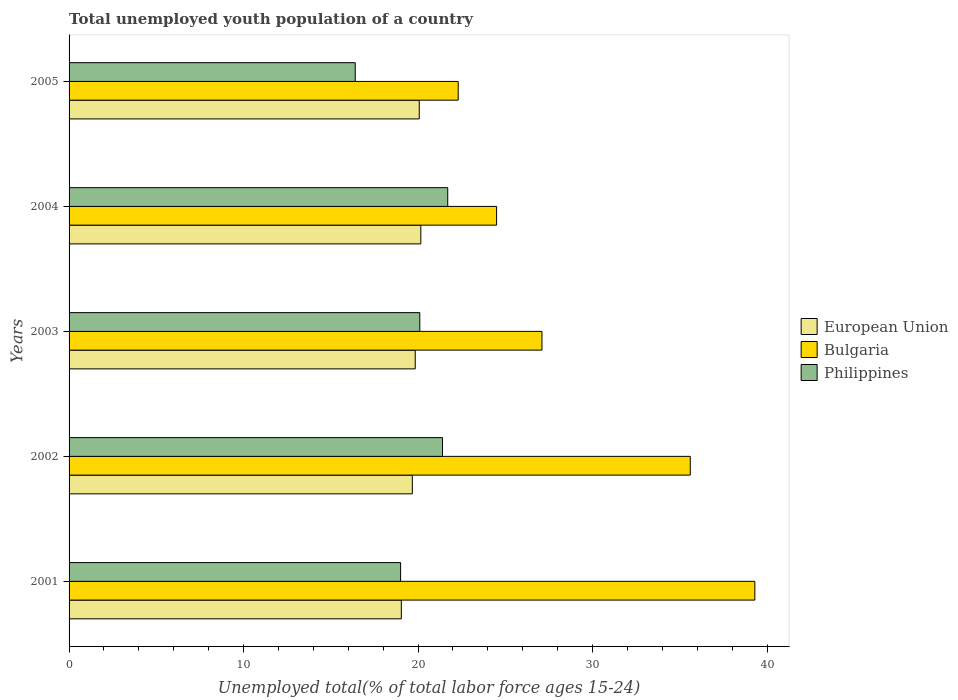How many groups of bars are there?
Give a very brief answer. 5. How many bars are there on the 4th tick from the top?
Give a very brief answer. 3. How many bars are there on the 2nd tick from the bottom?
Provide a succinct answer. 3. In how many cases, is the number of bars for a given year not equal to the number of legend labels?
Ensure brevity in your answer.  0. What is the percentage of total unemployed youth population of a country in European Union in 2001?
Provide a short and direct response. 19.04. Across all years, what is the maximum percentage of total unemployed youth population of a country in Philippines?
Keep it short and to the point. 21.7. Across all years, what is the minimum percentage of total unemployed youth population of a country in Philippines?
Your answer should be compact. 16.4. In which year was the percentage of total unemployed youth population of a country in European Union minimum?
Ensure brevity in your answer.  2001. What is the total percentage of total unemployed youth population of a country in Philippines in the graph?
Your answer should be very brief. 98.6. What is the difference between the percentage of total unemployed youth population of a country in Bulgaria in 2004 and that in 2005?
Offer a very short reply. 2.2. What is the difference between the percentage of total unemployed youth population of a country in Bulgaria in 2005 and the percentage of total unemployed youth population of a country in Philippines in 2001?
Your answer should be compact. 3.3. What is the average percentage of total unemployed youth population of a country in European Union per year?
Ensure brevity in your answer.  19.76. In the year 2002, what is the difference between the percentage of total unemployed youth population of a country in European Union and percentage of total unemployed youth population of a country in Bulgaria?
Offer a terse response. -15.93. What is the ratio of the percentage of total unemployed youth population of a country in European Union in 2003 to that in 2004?
Offer a terse response. 0.98. Is the difference between the percentage of total unemployed youth population of a country in European Union in 2003 and 2004 greater than the difference between the percentage of total unemployed youth population of a country in Bulgaria in 2003 and 2004?
Your answer should be very brief. No. What is the difference between the highest and the second highest percentage of total unemployed youth population of a country in Bulgaria?
Offer a very short reply. 3.7. What is the difference between the highest and the lowest percentage of total unemployed youth population of a country in European Union?
Your answer should be compact. 1.12. What does the 2nd bar from the top in 2003 represents?
Make the answer very short. Bulgaria. Is it the case that in every year, the sum of the percentage of total unemployed youth population of a country in Philippines and percentage of total unemployed youth population of a country in European Union is greater than the percentage of total unemployed youth population of a country in Bulgaria?
Offer a terse response. No. Are the values on the major ticks of X-axis written in scientific E-notation?
Keep it short and to the point. No. Does the graph contain any zero values?
Provide a short and direct response. No. Where does the legend appear in the graph?
Give a very brief answer. Center right. How many legend labels are there?
Provide a succinct answer. 3. What is the title of the graph?
Make the answer very short. Total unemployed youth population of a country. What is the label or title of the X-axis?
Your response must be concise. Unemployed total(% of total labor force ages 15-24). What is the Unemployed total(% of total labor force ages 15-24) in European Union in 2001?
Make the answer very short. 19.04. What is the Unemployed total(% of total labor force ages 15-24) of Bulgaria in 2001?
Give a very brief answer. 39.3. What is the Unemployed total(% of total labor force ages 15-24) in Philippines in 2001?
Provide a succinct answer. 19. What is the Unemployed total(% of total labor force ages 15-24) of European Union in 2002?
Your answer should be compact. 19.67. What is the Unemployed total(% of total labor force ages 15-24) in Bulgaria in 2002?
Give a very brief answer. 35.6. What is the Unemployed total(% of total labor force ages 15-24) in Philippines in 2002?
Your response must be concise. 21.4. What is the Unemployed total(% of total labor force ages 15-24) of European Union in 2003?
Your answer should be compact. 19.84. What is the Unemployed total(% of total labor force ages 15-24) of Bulgaria in 2003?
Your response must be concise. 27.1. What is the Unemployed total(% of total labor force ages 15-24) of Philippines in 2003?
Offer a very short reply. 20.1. What is the Unemployed total(% of total labor force ages 15-24) in European Union in 2004?
Keep it short and to the point. 20.16. What is the Unemployed total(% of total labor force ages 15-24) of Philippines in 2004?
Give a very brief answer. 21.7. What is the Unemployed total(% of total labor force ages 15-24) in European Union in 2005?
Your answer should be compact. 20.07. What is the Unemployed total(% of total labor force ages 15-24) in Bulgaria in 2005?
Provide a succinct answer. 22.3. What is the Unemployed total(% of total labor force ages 15-24) in Philippines in 2005?
Ensure brevity in your answer.  16.4. Across all years, what is the maximum Unemployed total(% of total labor force ages 15-24) in European Union?
Give a very brief answer. 20.16. Across all years, what is the maximum Unemployed total(% of total labor force ages 15-24) in Bulgaria?
Ensure brevity in your answer.  39.3. Across all years, what is the maximum Unemployed total(% of total labor force ages 15-24) in Philippines?
Offer a very short reply. 21.7. Across all years, what is the minimum Unemployed total(% of total labor force ages 15-24) in European Union?
Your answer should be very brief. 19.04. Across all years, what is the minimum Unemployed total(% of total labor force ages 15-24) in Bulgaria?
Make the answer very short. 22.3. Across all years, what is the minimum Unemployed total(% of total labor force ages 15-24) of Philippines?
Keep it short and to the point. 16.4. What is the total Unemployed total(% of total labor force ages 15-24) in European Union in the graph?
Provide a short and direct response. 98.78. What is the total Unemployed total(% of total labor force ages 15-24) in Bulgaria in the graph?
Your response must be concise. 148.8. What is the total Unemployed total(% of total labor force ages 15-24) in Philippines in the graph?
Your answer should be compact. 98.6. What is the difference between the Unemployed total(% of total labor force ages 15-24) of European Union in 2001 and that in 2002?
Offer a terse response. -0.63. What is the difference between the Unemployed total(% of total labor force ages 15-24) of European Union in 2001 and that in 2003?
Keep it short and to the point. -0.8. What is the difference between the Unemployed total(% of total labor force ages 15-24) in Bulgaria in 2001 and that in 2003?
Ensure brevity in your answer.  12.2. What is the difference between the Unemployed total(% of total labor force ages 15-24) of Philippines in 2001 and that in 2003?
Ensure brevity in your answer.  -1.1. What is the difference between the Unemployed total(% of total labor force ages 15-24) of European Union in 2001 and that in 2004?
Make the answer very short. -1.12. What is the difference between the Unemployed total(% of total labor force ages 15-24) of Philippines in 2001 and that in 2004?
Provide a succinct answer. -2.7. What is the difference between the Unemployed total(% of total labor force ages 15-24) in European Union in 2001 and that in 2005?
Make the answer very short. -1.03. What is the difference between the Unemployed total(% of total labor force ages 15-24) in Philippines in 2001 and that in 2005?
Offer a very short reply. 2.6. What is the difference between the Unemployed total(% of total labor force ages 15-24) in European Union in 2002 and that in 2003?
Ensure brevity in your answer.  -0.17. What is the difference between the Unemployed total(% of total labor force ages 15-24) in Bulgaria in 2002 and that in 2003?
Make the answer very short. 8.5. What is the difference between the Unemployed total(% of total labor force ages 15-24) of European Union in 2002 and that in 2004?
Your answer should be compact. -0.49. What is the difference between the Unemployed total(% of total labor force ages 15-24) of Bulgaria in 2002 and that in 2004?
Offer a terse response. 11.1. What is the difference between the Unemployed total(% of total labor force ages 15-24) in Philippines in 2002 and that in 2004?
Your response must be concise. -0.3. What is the difference between the Unemployed total(% of total labor force ages 15-24) of European Union in 2002 and that in 2005?
Your answer should be very brief. -0.4. What is the difference between the Unemployed total(% of total labor force ages 15-24) in Bulgaria in 2002 and that in 2005?
Your answer should be compact. 13.3. What is the difference between the Unemployed total(% of total labor force ages 15-24) in Philippines in 2002 and that in 2005?
Your answer should be very brief. 5. What is the difference between the Unemployed total(% of total labor force ages 15-24) of European Union in 2003 and that in 2004?
Offer a very short reply. -0.32. What is the difference between the Unemployed total(% of total labor force ages 15-24) of Bulgaria in 2003 and that in 2004?
Your answer should be very brief. 2.6. What is the difference between the Unemployed total(% of total labor force ages 15-24) of Philippines in 2003 and that in 2004?
Give a very brief answer. -1.6. What is the difference between the Unemployed total(% of total labor force ages 15-24) of European Union in 2003 and that in 2005?
Your answer should be compact. -0.23. What is the difference between the Unemployed total(% of total labor force ages 15-24) in Bulgaria in 2003 and that in 2005?
Your answer should be very brief. 4.8. What is the difference between the Unemployed total(% of total labor force ages 15-24) of Philippines in 2003 and that in 2005?
Provide a short and direct response. 3.7. What is the difference between the Unemployed total(% of total labor force ages 15-24) of European Union in 2004 and that in 2005?
Your answer should be very brief. 0.09. What is the difference between the Unemployed total(% of total labor force ages 15-24) in Philippines in 2004 and that in 2005?
Give a very brief answer. 5.3. What is the difference between the Unemployed total(% of total labor force ages 15-24) of European Union in 2001 and the Unemployed total(% of total labor force ages 15-24) of Bulgaria in 2002?
Your response must be concise. -16.56. What is the difference between the Unemployed total(% of total labor force ages 15-24) of European Union in 2001 and the Unemployed total(% of total labor force ages 15-24) of Philippines in 2002?
Your answer should be compact. -2.36. What is the difference between the Unemployed total(% of total labor force ages 15-24) in European Union in 2001 and the Unemployed total(% of total labor force ages 15-24) in Bulgaria in 2003?
Your answer should be compact. -8.06. What is the difference between the Unemployed total(% of total labor force ages 15-24) of European Union in 2001 and the Unemployed total(% of total labor force ages 15-24) of Philippines in 2003?
Offer a terse response. -1.06. What is the difference between the Unemployed total(% of total labor force ages 15-24) of Bulgaria in 2001 and the Unemployed total(% of total labor force ages 15-24) of Philippines in 2003?
Offer a very short reply. 19.2. What is the difference between the Unemployed total(% of total labor force ages 15-24) of European Union in 2001 and the Unemployed total(% of total labor force ages 15-24) of Bulgaria in 2004?
Provide a short and direct response. -5.46. What is the difference between the Unemployed total(% of total labor force ages 15-24) in European Union in 2001 and the Unemployed total(% of total labor force ages 15-24) in Philippines in 2004?
Make the answer very short. -2.66. What is the difference between the Unemployed total(% of total labor force ages 15-24) in Bulgaria in 2001 and the Unemployed total(% of total labor force ages 15-24) in Philippines in 2004?
Provide a succinct answer. 17.6. What is the difference between the Unemployed total(% of total labor force ages 15-24) of European Union in 2001 and the Unemployed total(% of total labor force ages 15-24) of Bulgaria in 2005?
Provide a succinct answer. -3.26. What is the difference between the Unemployed total(% of total labor force ages 15-24) in European Union in 2001 and the Unemployed total(% of total labor force ages 15-24) in Philippines in 2005?
Your answer should be compact. 2.64. What is the difference between the Unemployed total(% of total labor force ages 15-24) in Bulgaria in 2001 and the Unemployed total(% of total labor force ages 15-24) in Philippines in 2005?
Provide a short and direct response. 22.9. What is the difference between the Unemployed total(% of total labor force ages 15-24) of European Union in 2002 and the Unemployed total(% of total labor force ages 15-24) of Bulgaria in 2003?
Ensure brevity in your answer.  -7.43. What is the difference between the Unemployed total(% of total labor force ages 15-24) in European Union in 2002 and the Unemployed total(% of total labor force ages 15-24) in Philippines in 2003?
Your response must be concise. -0.43. What is the difference between the Unemployed total(% of total labor force ages 15-24) of Bulgaria in 2002 and the Unemployed total(% of total labor force ages 15-24) of Philippines in 2003?
Offer a very short reply. 15.5. What is the difference between the Unemployed total(% of total labor force ages 15-24) in European Union in 2002 and the Unemployed total(% of total labor force ages 15-24) in Bulgaria in 2004?
Your answer should be very brief. -4.83. What is the difference between the Unemployed total(% of total labor force ages 15-24) of European Union in 2002 and the Unemployed total(% of total labor force ages 15-24) of Philippines in 2004?
Keep it short and to the point. -2.03. What is the difference between the Unemployed total(% of total labor force ages 15-24) in Bulgaria in 2002 and the Unemployed total(% of total labor force ages 15-24) in Philippines in 2004?
Your answer should be compact. 13.9. What is the difference between the Unemployed total(% of total labor force ages 15-24) of European Union in 2002 and the Unemployed total(% of total labor force ages 15-24) of Bulgaria in 2005?
Your response must be concise. -2.63. What is the difference between the Unemployed total(% of total labor force ages 15-24) of European Union in 2002 and the Unemployed total(% of total labor force ages 15-24) of Philippines in 2005?
Offer a very short reply. 3.27. What is the difference between the Unemployed total(% of total labor force ages 15-24) in European Union in 2003 and the Unemployed total(% of total labor force ages 15-24) in Bulgaria in 2004?
Provide a succinct answer. -4.66. What is the difference between the Unemployed total(% of total labor force ages 15-24) in European Union in 2003 and the Unemployed total(% of total labor force ages 15-24) in Philippines in 2004?
Give a very brief answer. -1.86. What is the difference between the Unemployed total(% of total labor force ages 15-24) in Bulgaria in 2003 and the Unemployed total(% of total labor force ages 15-24) in Philippines in 2004?
Provide a short and direct response. 5.4. What is the difference between the Unemployed total(% of total labor force ages 15-24) of European Union in 2003 and the Unemployed total(% of total labor force ages 15-24) of Bulgaria in 2005?
Offer a terse response. -2.46. What is the difference between the Unemployed total(% of total labor force ages 15-24) in European Union in 2003 and the Unemployed total(% of total labor force ages 15-24) in Philippines in 2005?
Offer a very short reply. 3.44. What is the difference between the Unemployed total(% of total labor force ages 15-24) in Bulgaria in 2003 and the Unemployed total(% of total labor force ages 15-24) in Philippines in 2005?
Your answer should be compact. 10.7. What is the difference between the Unemployed total(% of total labor force ages 15-24) of European Union in 2004 and the Unemployed total(% of total labor force ages 15-24) of Bulgaria in 2005?
Offer a terse response. -2.14. What is the difference between the Unemployed total(% of total labor force ages 15-24) in European Union in 2004 and the Unemployed total(% of total labor force ages 15-24) in Philippines in 2005?
Give a very brief answer. 3.76. What is the average Unemployed total(% of total labor force ages 15-24) of European Union per year?
Your answer should be very brief. 19.76. What is the average Unemployed total(% of total labor force ages 15-24) in Bulgaria per year?
Give a very brief answer. 29.76. What is the average Unemployed total(% of total labor force ages 15-24) of Philippines per year?
Keep it short and to the point. 19.72. In the year 2001, what is the difference between the Unemployed total(% of total labor force ages 15-24) of European Union and Unemployed total(% of total labor force ages 15-24) of Bulgaria?
Your response must be concise. -20.26. In the year 2001, what is the difference between the Unemployed total(% of total labor force ages 15-24) of European Union and Unemployed total(% of total labor force ages 15-24) of Philippines?
Your answer should be compact. 0.04. In the year 2001, what is the difference between the Unemployed total(% of total labor force ages 15-24) of Bulgaria and Unemployed total(% of total labor force ages 15-24) of Philippines?
Your answer should be very brief. 20.3. In the year 2002, what is the difference between the Unemployed total(% of total labor force ages 15-24) in European Union and Unemployed total(% of total labor force ages 15-24) in Bulgaria?
Offer a terse response. -15.93. In the year 2002, what is the difference between the Unemployed total(% of total labor force ages 15-24) in European Union and Unemployed total(% of total labor force ages 15-24) in Philippines?
Make the answer very short. -1.73. In the year 2003, what is the difference between the Unemployed total(% of total labor force ages 15-24) of European Union and Unemployed total(% of total labor force ages 15-24) of Bulgaria?
Give a very brief answer. -7.26. In the year 2003, what is the difference between the Unemployed total(% of total labor force ages 15-24) of European Union and Unemployed total(% of total labor force ages 15-24) of Philippines?
Make the answer very short. -0.26. In the year 2003, what is the difference between the Unemployed total(% of total labor force ages 15-24) of Bulgaria and Unemployed total(% of total labor force ages 15-24) of Philippines?
Offer a very short reply. 7. In the year 2004, what is the difference between the Unemployed total(% of total labor force ages 15-24) of European Union and Unemployed total(% of total labor force ages 15-24) of Bulgaria?
Make the answer very short. -4.34. In the year 2004, what is the difference between the Unemployed total(% of total labor force ages 15-24) of European Union and Unemployed total(% of total labor force ages 15-24) of Philippines?
Keep it short and to the point. -1.54. In the year 2005, what is the difference between the Unemployed total(% of total labor force ages 15-24) in European Union and Unemployed total(% of total labor force ages 15-24) in Bulgaria?
Your answer should be very brief. -2.23. In the year 2005, what is the difference between the Unemployed total(% of total labor force ages 15-24) of European Union and Unemployed total(% of total labor force ages 15-24) of Philippines?
Keep it short and to the point. 3.67. In the year 2005, what is the difference between the Unemployed total(% of total labor force ages 15-24) of Bulgaria and Unemployed total(% of total labor force ages 15-24) of Philippines?
Your response must be concise. 5.9. What is the ratio of the Unemployed total(% of total labor force ages 15-24) of European Union in 2001 to that in 2002?
Your answer should be very brief. 0.97. What is the ratio of the Unemployed total(% of total labor force ages 15-24) of Bulgaria in 2001 to that in 2002?
Provide a short and direct response. 1.1. What is the ratio of the Unemployed total(% of total labor force ages 15-24) in Philippines in 2001 to that in 2002?
Keep it short and to the point. 0.89. What is the ratio of the Unemployed total(% of total labor force ages 15-24) in European Union in 2001 to that in 2003?
Make the answer very short. 0.96. What is the ratio of the Unemployed total(% of total labor force ages 15-24) in Bulgaria in 2001 to that in 2003?
Your answer should be very brief. 1.45. What is the ratio of the Unemployed total(% of total labor force ages 15-24) of Philippines in 2001 to that in 2003?
Make the answer very short. 0.95. What is the ratio of the Unemployed total(% of total labor force ages 15-24) in European Union in 2001 to that in 2004?
Ensure brevity in your answer.  0.94. What is the ratio of the Unemployed total(% of total labor force ages 15-24) in Bulgaria in 2001 to that in 2004?
Keep it short and to the point. 1.6. What is the ratio of the Unemployed total(% of total labor force ages 15-24) in Philippines in 2001 to that in 2004?
Give a very brief answer. 0.88. What is the ratio of the Unemployed total(% of total labor force ages 15-24) of European Union in 2001 to that in 2005?
Provide a succinct answer. 0.95. What is the ratio of the Unemployed total(% of total labor force ages 15-24) of Bulgaria in 2001 to that in 2005?
Keep it short and to the point. 1.76. What is the ratio of the Unemployed total(% of total labor force ages 15-24) in Philippines in 2001 to that in 2005?
Offer a very short reply. 1.16. What is the ratio of the Unemployed total(% of total labor force ages 15-24) of European Union in 2002 to that in 2003?
Provide a short and direct response. 0.99. What is the ratio of the Unemployed total(% of total labor force ages 15-24) of Bulgaria in 2002 to that in 2003?
Your response must be concise. 1.31. What is the ratio of the Unemployed total(% of total labor force ages 15-24) in Philippines in 2002 to that in 2003?
Provide a short and direct response. 1.06. What is the ratio of the Unemployed total(% of total labor force ages 15-24) in European Union in 2002 to that in 2004?
Your response must be concise. 0.98. What is the ratio of the Unemployed total(% of total labor force ages 15-24) of Bulgaria in 2002 to that in 2004?
Offer a very short reply. 1.45. What is the ratio of the Unemployed total(% of total labor force ages 15-24) of Philippines in 2002 to that in 2004?
Give a very brief answer. 0.99. What is the ratio of the Unemployed total(% of total labor force ages 15-24) in European Union in 2002 to that in 2005?
Your answer should be compact. 0.98. What is the ratio of the Unemployed total(% of total labor force ages 15-24) of Bulgaria in 2002 to that in 2005?
Keep it short and to the point. 1.6. What is the ratio of the Unemployed total(% of total labor force ages 15-24) of Philippines in 2002 to that in 2005?
Make the answer very short. 1.3. What is the ratio of the Unemployed total(% of total labor force ages 15-24) of European Union in 2003 to that in 2004?
Keep it short and to the point. 0.98. What is the ratio of the Unemployed total(% of total labor force ages 15-24) in Bulgaria in 2003 to that in 2004?
Provide a succinct answer. 1.11. What is the ratio of the Unemployed total(% of total labor force ages 15-24) in Philippines in 2003 to that in 2004?
Provide a succinct answer. 0.93. What is the ratio of the Unemployed total(% of total labor force ages 15-24) in Bulgaria in 2003 to that in 2005?
Provide a succinct answer. 1.22. What is the ratio of the Unemployed total(% of total labor force ages 15-24) of Philippines in 2003 to that in 2005?
Offer a terse response. 1.23. What is the ratio of the Unemployed total(% of total labor force ages 15-24) of Bulgaria in 2004 to that in 2005?
Your answer should be very brief. 1.1. What is the ratio of the Unemployed total(% of total labor force ages 15-24) of Philippines in 2004 to that in 2005?
Give a very brief answer. 1.32. What is the difference between the highest and the second highest Unemployed total(% of total labor force ages 15-24) in European Union?
Ensure brevity in your answer.  0.09. What is the difference between the highest and the lowest Unemployed total(% of total labor force ages 15-24) of European Union?
Provide a succinct answer. 1.12. What is the difference between the highest and the lowest Unemployed total(% of total labor force ages 15-24) in Bulgaria?
Your answer should be compact. 17. What is the difference between the highest and the lowest Unemployed total(% of total labor force ages 15-24) of Philippines?
Your answer should be compact. 5.3. 